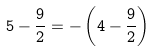<formula> <loc_0><loc_0><loc_500><loc_500>5 - { \frac { 9 } { 2 } } = - \left ( 4 - { \frac { 9 } { 2 } } \right )</formula> 